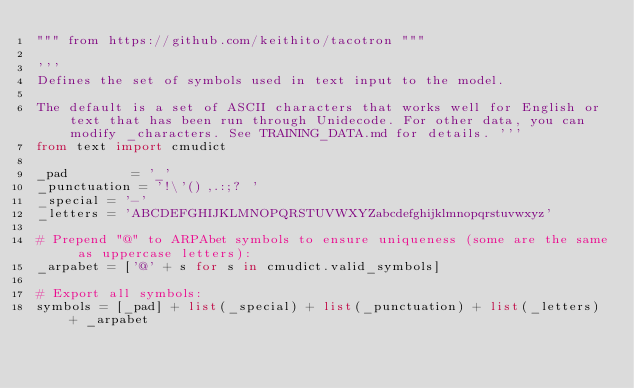Convert code to text. <code><loc_0><loc_0><loc_500><loc_500><_Python_>""" from https://github.com/keithito/tacotron """

'''
Defines the set of symbols used in text input to the model.

The default is a set of ASCII characters that works well for English or text that has been run through Unidecode. For other data, you can modify _characters. See TRAINING_DATA.md for details. '''
from text import cmudict

_pad        = '_'
_punctuation = '!\'(),.:;? '
_special = '-'
_letters = 'ABCDEFGHIJKLMNOPQRSTUVWXYZabcdefghijklmnopqrstuvwxyz'

# Prepend "@" to ARPAbet symbols to ensure uniqueness (some are the same as uppercase letters):
_arpabet = ['@' + s for s in cmudict.valid_symbols]

# Export all symbols:
symbols = [_pad] + list(_special) + list(_punctuation) + list(_letters) + _arpabet
</code> 